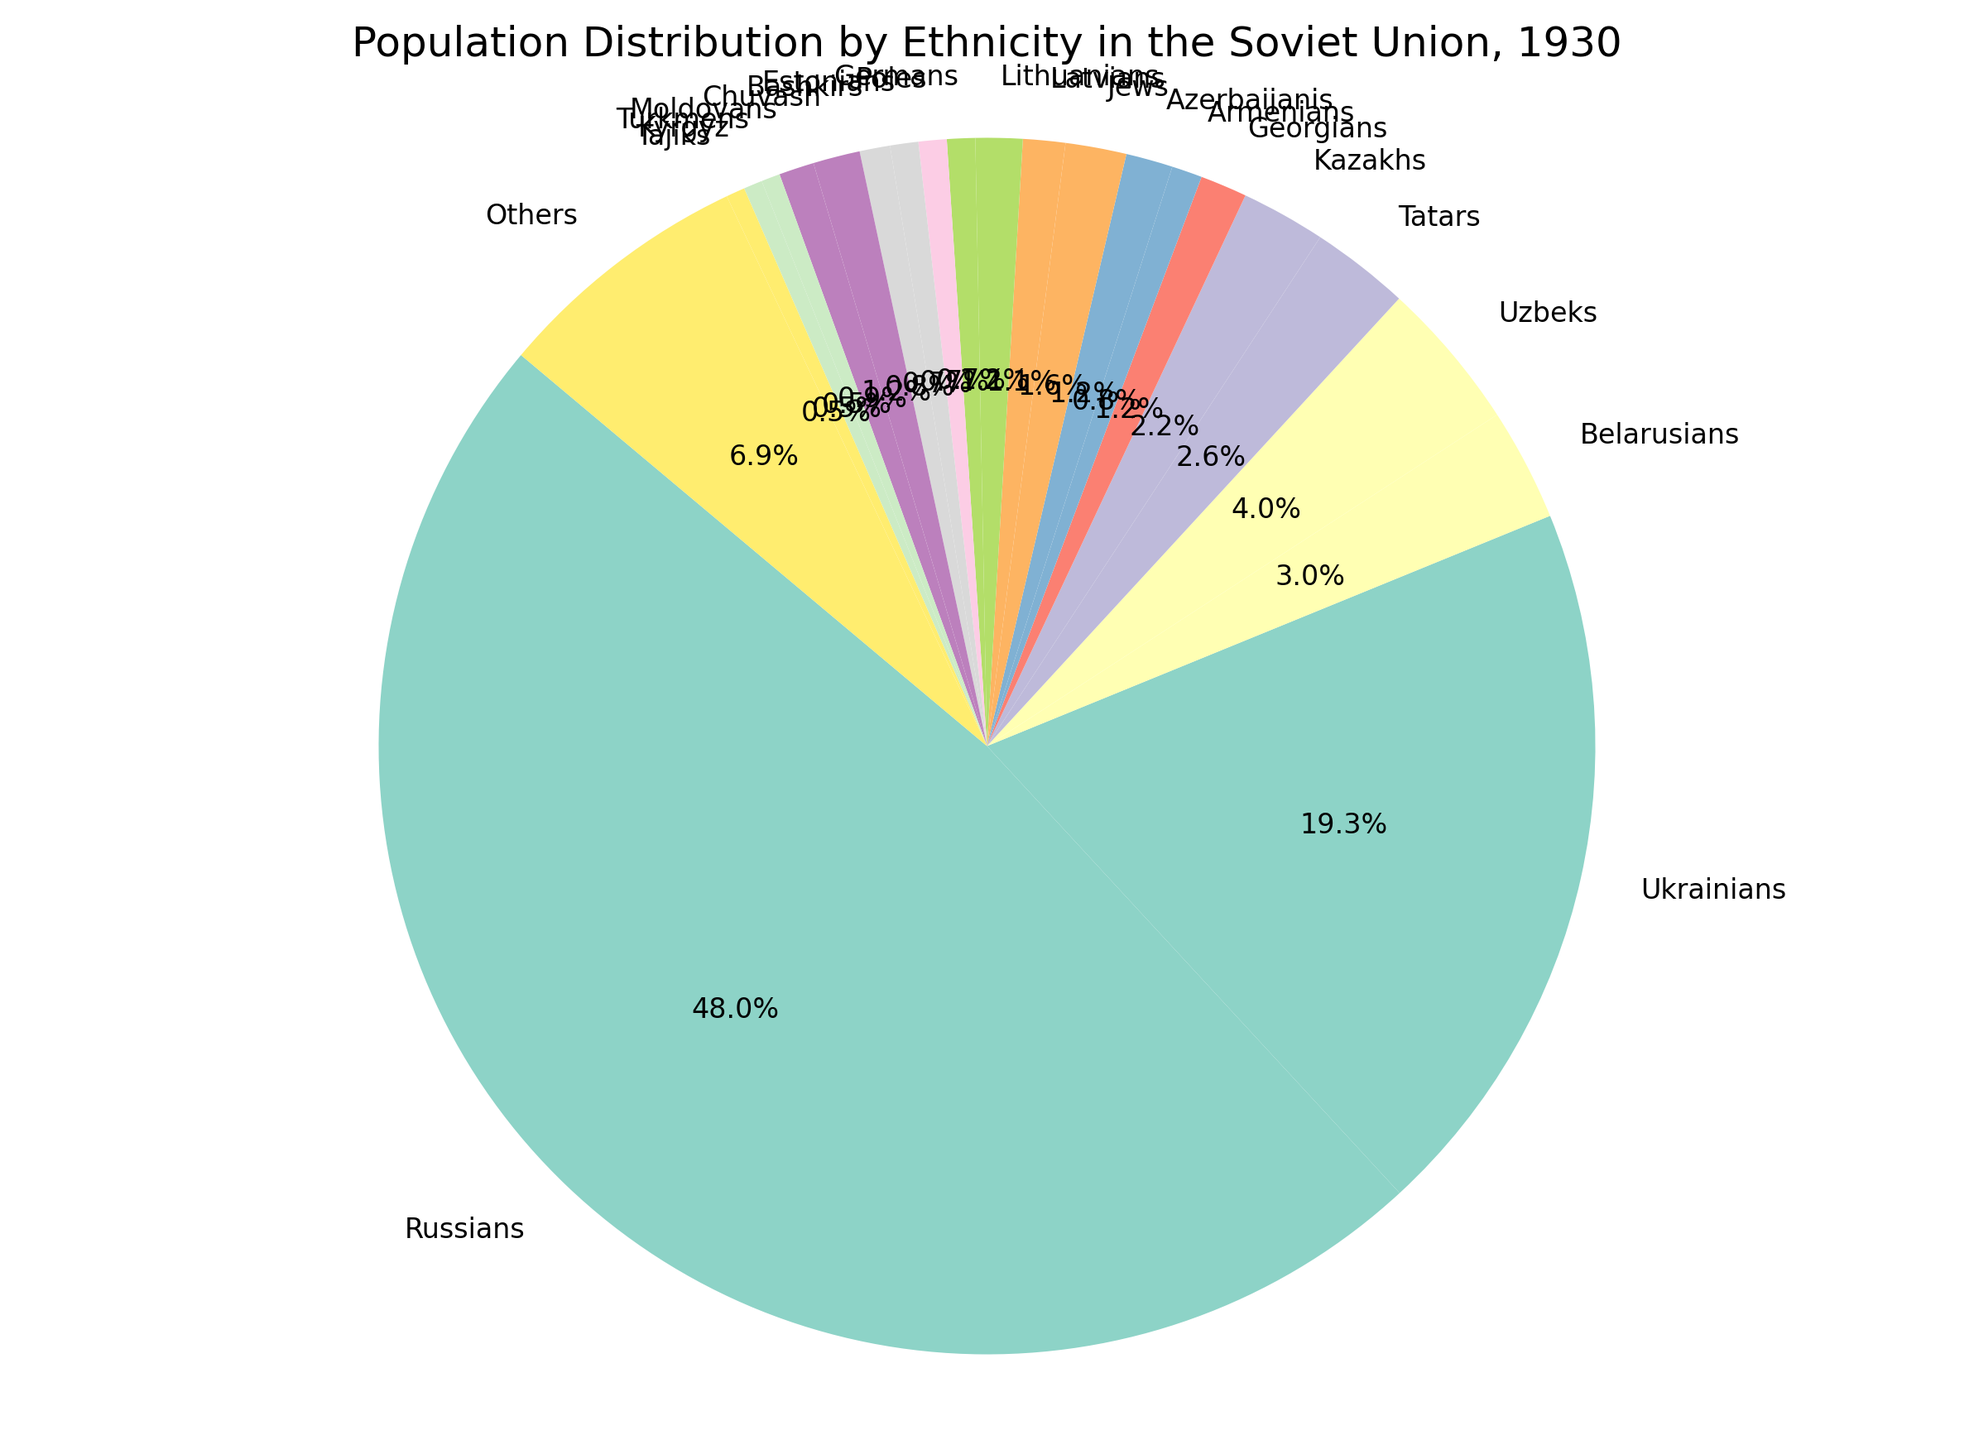How much larger is the population of Russians compared to Ukrainians in 1930? To find out how much larger the Russian population is compared to the Ukrainian population, subtract the population of Ukrainians (31,000 thousand) from the population of Russians (77,000 thousand): 77,000 - 31,000 = 46,000.
Answer: 46,000 Which ethnic group is the third most populous? To determine the third most populous group, after Russians (77,000 thousand) and Ukrainians (31,000 thousand), we look through the data and see that the Belarusians (4,800 thousand) are the next highest population.
Answer: Belarusians What is the combined population of Georgians, Armenians, and Azerbaijanis? Add the populations of Georgians (2,000 thousand), Armenians (1,300 thousand), and Azerbaijanis (2,000 thousand): 2,000 + 1,300 + 2,000 = 5,300 thousand.
Answer: 5,300 Is the population of Kazakhs greater than that of Uzbeks? Compare the population of Kazakhs (3,600 thousand) and Uzbeks (6,400 thousand). Since 3,600 is less than 6,400, the Kazakhs have a smaller population than the Uzbeks.
Answer: No What proportion of the total population do the "Others" category represent? To find this, calculate the total population by summing up all the provided populations: 77,000 + 31,000 + 4,800 + 6,400 + 4,200 + 3,600 + 2,000 + 1,300 + 2,000 + 2,600 + 1,800 + 2,000 + 1,200 + 1,200 + 1,200 + 1,300 + 2,000 + 1,500 + 800 + 800 + 800 + 11,000 = 186,500. Then calculate the proportion of the "Others" category: (11,000 / 186,500) * 100 ≈ 5.9%.
Answer: 5.9% How many times the population of Jews is the population of Germans? Divide the population of Jews (2,600 thousand) by the population of Germans (1,200 thousand): 2,600 / 1,200 ≈ 2.17.
Answer: 2.17 Among the listed ethnicities, which groups have exactly the same population? Identifying ethnic groups with identical populations, we see that Lithuanians, Azerbaijanis, and Estonians all have a population of 2,000 thousand, while Germans and Poles both have a population of 1,200 thousand.
Answer: Lithuanians, Azerbaijanis, Estonians; Germans, Poles What is the total population of ethnic groups with a population less than 2,000 thousand? Sum the populations of the groups with less than 2,000: Armenians (1,300), Germans (1,200), Poles (1,200), Estonians (1,200), Bashkirs (1,300), Moldovans (1,500), Turkmens (800), Kyrgyz (800), Tajiks (800): 1,300 + 1,200 + 1,200 + 1,200 + 1,300 + 1,500 + 800 + 800 + 800 = 9,100 thousand.
Answer: 9,100 If you grouped all the ethnicities with a population above 10,000 thousand, what percentage of the total population would they constitute? First, find the sum of populations above 10,000: Russians (77,000), Ukrainians (31,000). Sum them: 77,000 + 31,000 = 108,000. Using the total population of 186,500, calculate the percentage: (108,000 / 186,500) * 100 ≈ 57.9%.
Answer: 57.9% What is the average population size of the ethnic groups listed? Calculate the total population: 186,500 thousand. There are 22 listed groups, so divide the total by the number of groups: 186,500 / 22 ≈ 8,477.27 thousand.
Answer: 8,477.27 